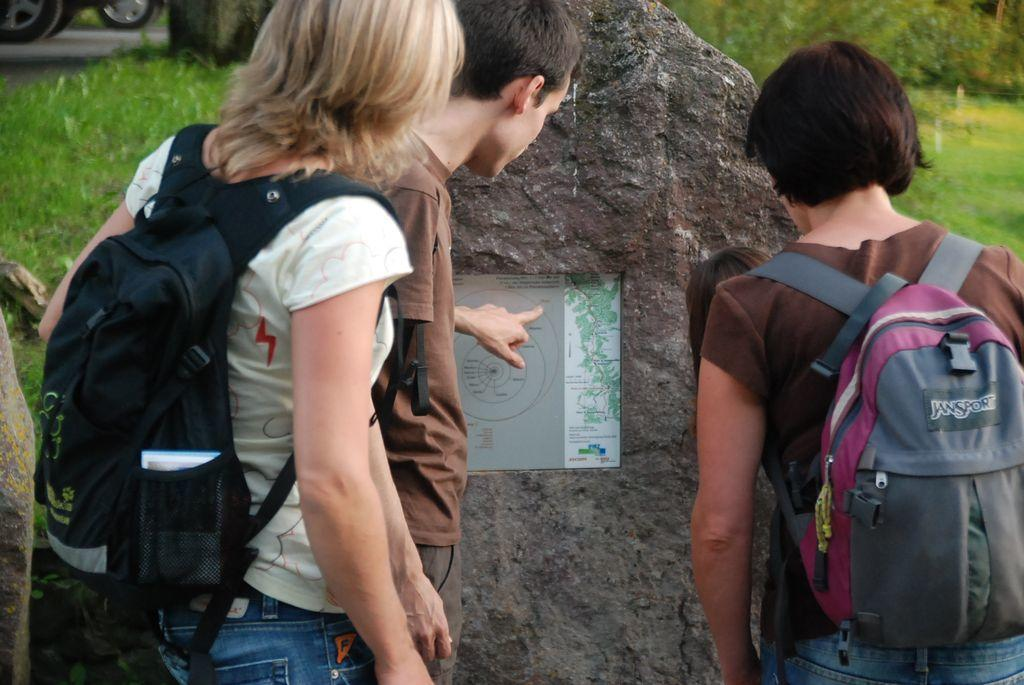<image>
Relay a brief, clear account of the picture shown. Three young backpackers, one with a JanSport backpack, looking at a map on the side of a rock. 